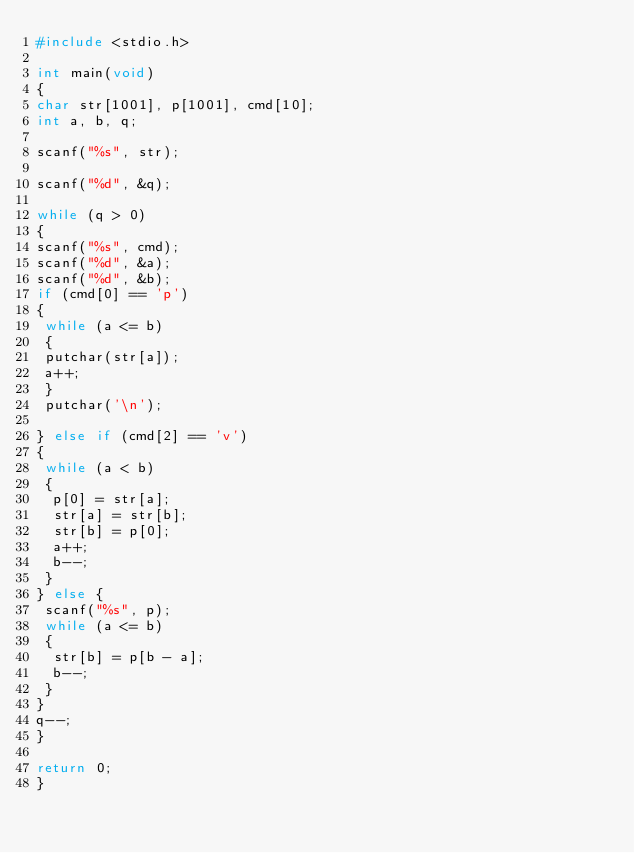<code> <loc_0><loc_0><loc_500><loc_500><_C_>#include <stdio.h>
    
int main(void)
{
char str[1001], p[1001], cmd[10];
int a, b, q;
    
scanf("%s", str);
    
scanf("%d", &q);
    
while (q > 0)
{
scanf("%s", cmd);
scanf("%d", &a);
scanf("%d", &b);
if (cmd[0] == 'p')
{
 while (a <= b)
 {
 putchar(str[a]);
 a++;
 }
 putchar('\n');
    
} else if (cmd[2] == 'v')
{
 while (a < b)
 {
  p[0] = str[a];
  str[a] = str[b];
  str[b] = p[0];
  a++;
  b--;
 }
} else {
 scanf("%s", p);
 while (a <= b)
 {
  str[b] = p[b - a];
  b--;
 }
}
q--;
}
    
return 0;
}
</code> 